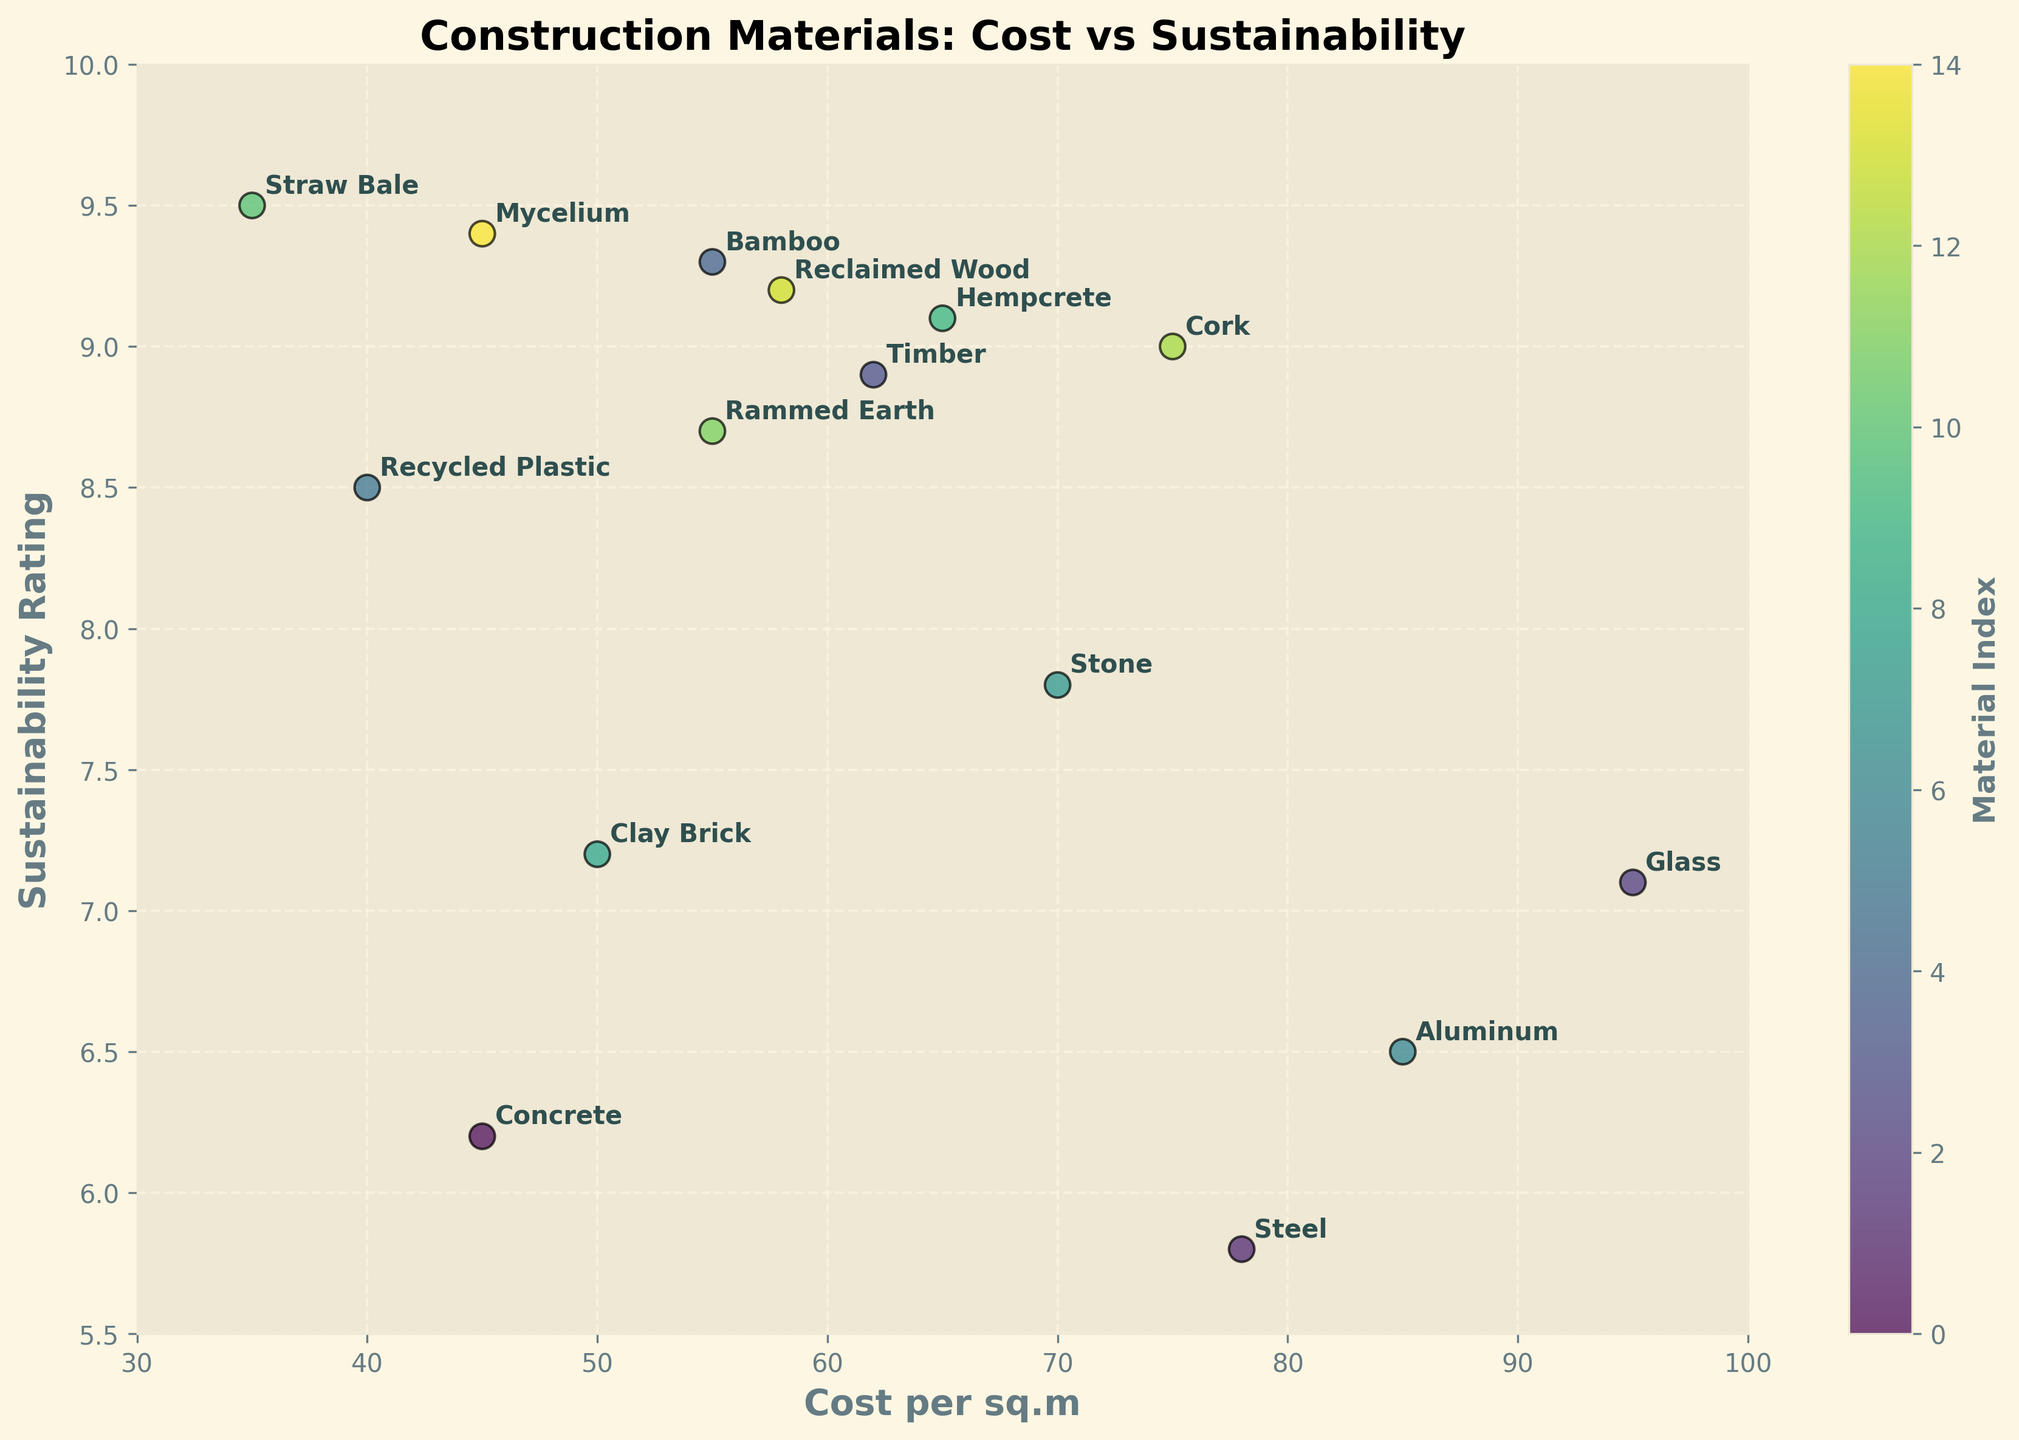How many data points represent construction materials in the plot? Count the number of scatter points; each represents a construction material.
Answer: 15 What is the title of the plot? Look at the top of the plot to find the title.
Answer: Construction Materials: Cost vs Sustainability Which material has the highest sustainability rating? Look for the scatter point with the highest y-value and refer to its annotation.
Answer: Straw Bale What material has the lowest cost per square meter? Examine the x-axis for the point closest to the left and note its annotation.
Answer: Straw Bale Which materials have costs above 80 per sq.m? Identify the scatter points positioned to the right of 80 on the x-axis and check their annotations.
Answer: Glass, Aluminum What is the difference in sustainability rating between Bamboo and Steel? Bamboo's rating is 9.3, and Steel's is 5.8. Subtract Steel's rating from Bamboo's. 9.3 - 5.8 = 3.5
Answer: 3.5 Which material offers the best combination of low cost and high sustainability rating? Find the material with the lowest x-value and highest y-value that is annotated near the top left area of the plot.
Answer: Straw Bale How does the sustainability of Timber compare to Recycled Plastic? Timber's sustainability rating is 8.9, and Recycled Plastic's is 8.5. Compare both values.
Answer: Timber has a higher sustainability rating Which material has both a high cost and a low sustainability rating? Look for scatter points in the top right quadrant with annotations indicating both high cost and low sustainability rating.
Answer: Glass What is the median cost per square meter of all materials? Arrange all cost values in ascending order: [35, 40, 45, 45, 50, 55, 55, 58, 62, 65, 70, 75, 78, 85, 95]. The middle (eighth) value is 58.
Answer: 58 